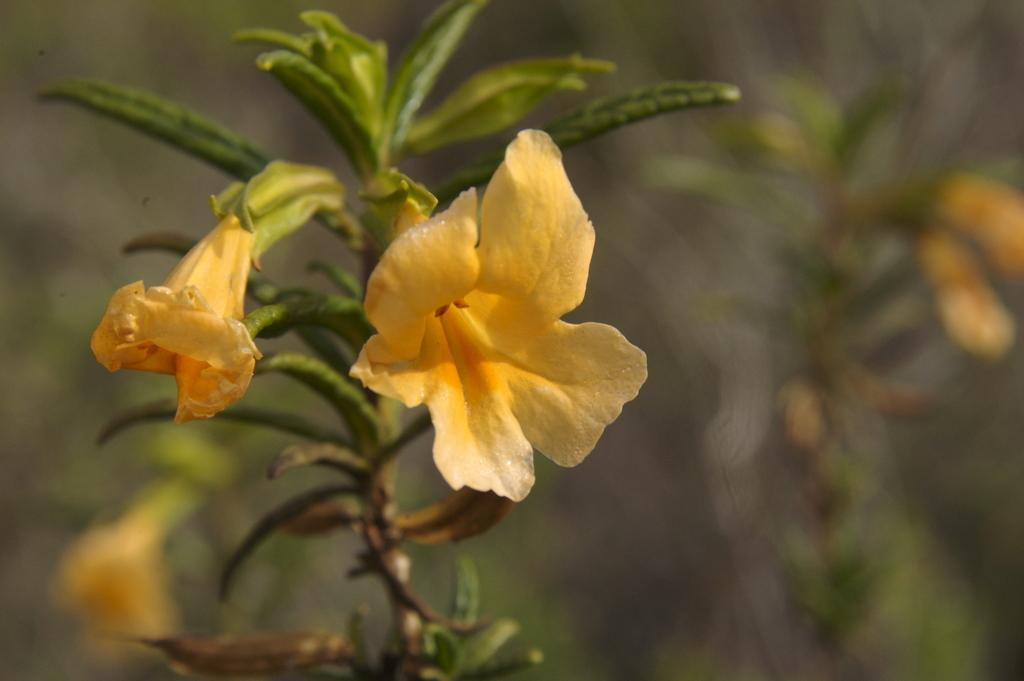What type of plant is featured in the image? There is a plant with flowers in the image. Can you describe the background of the image? The background of the image is blurred. Are there any other plants with flowers visible in the image? Yes, there are additional plants with flowers visible in the background. What type of pies are being served in the hospital where the zebra is located? There is no mention of pies, a hospital, or a zebra in the image. 